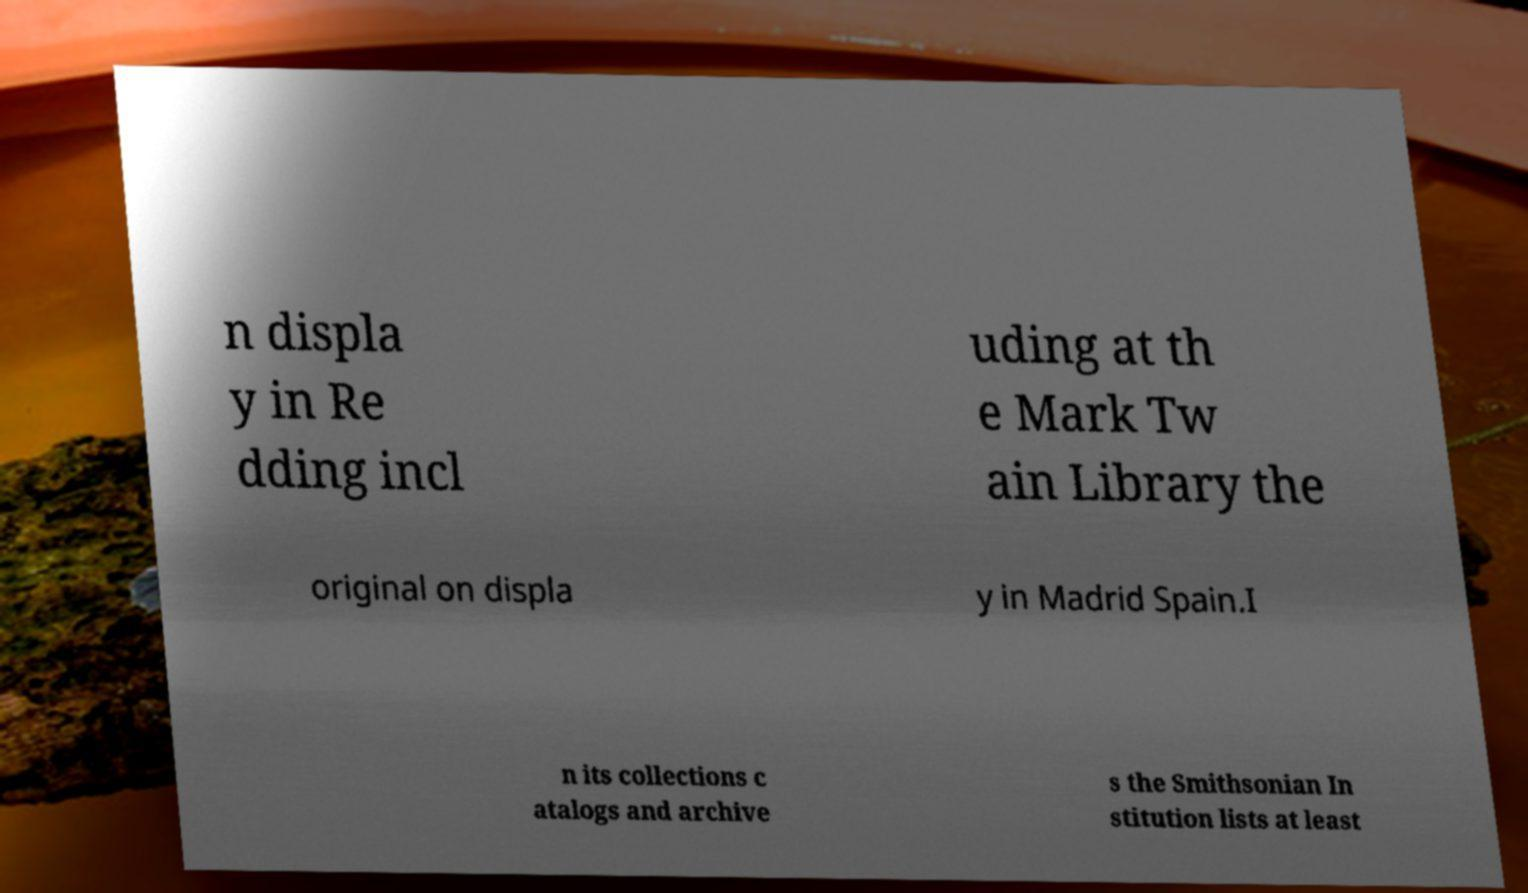Please identify and transcribe the text found in this image. n displa y in Re dding incl uding at th e Mark Tw ain Library the original on displa y in Madrid Spain.I n its collections c atalogs and archive s the Smithsonian In stitution lists at least 